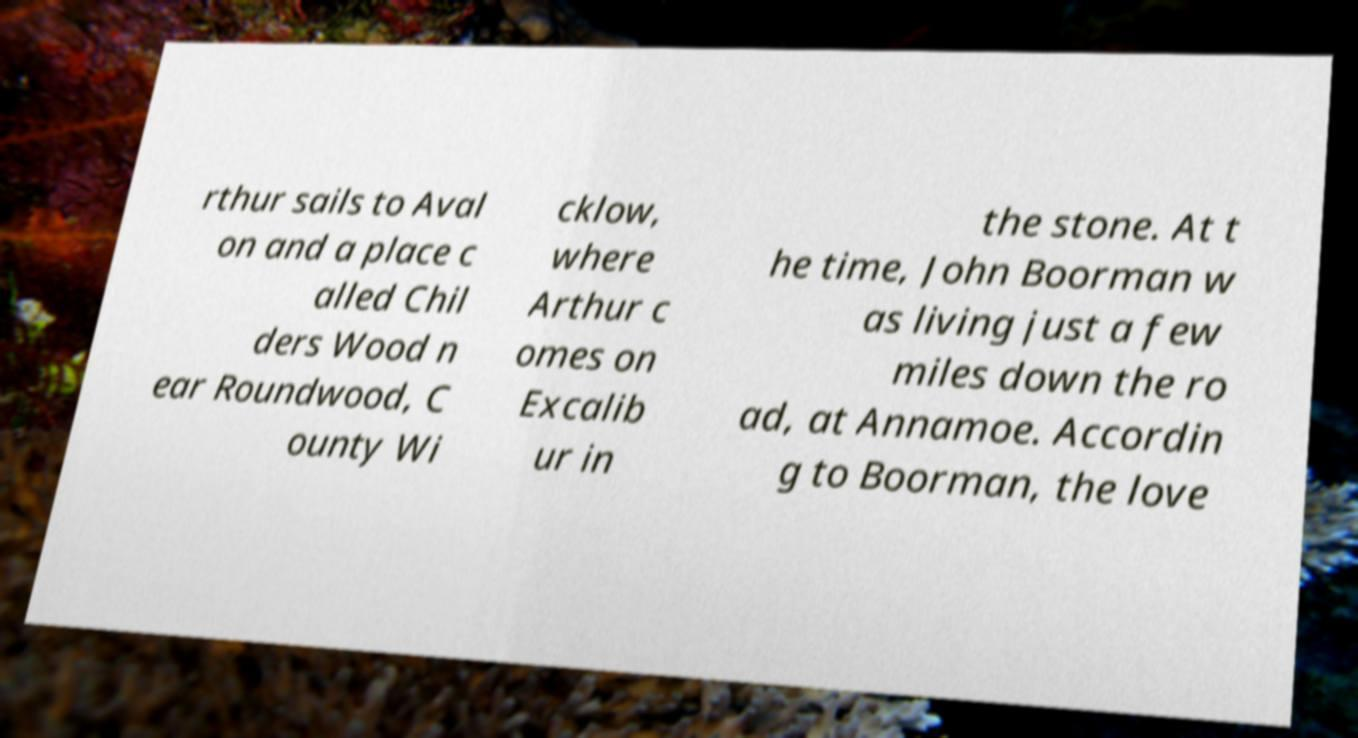Please identify and transcribe the text found in this image. rthur sails to Aval on and a place c alled Chil ders Wood n ear Roundwood, C ounty Wi cklow, where Arthur c omes on Excalib ur in the stone. At t he time, John Boorman w as living just a few miles down the ro ad, at Annamoe. Accordin g to Boorman, the love 